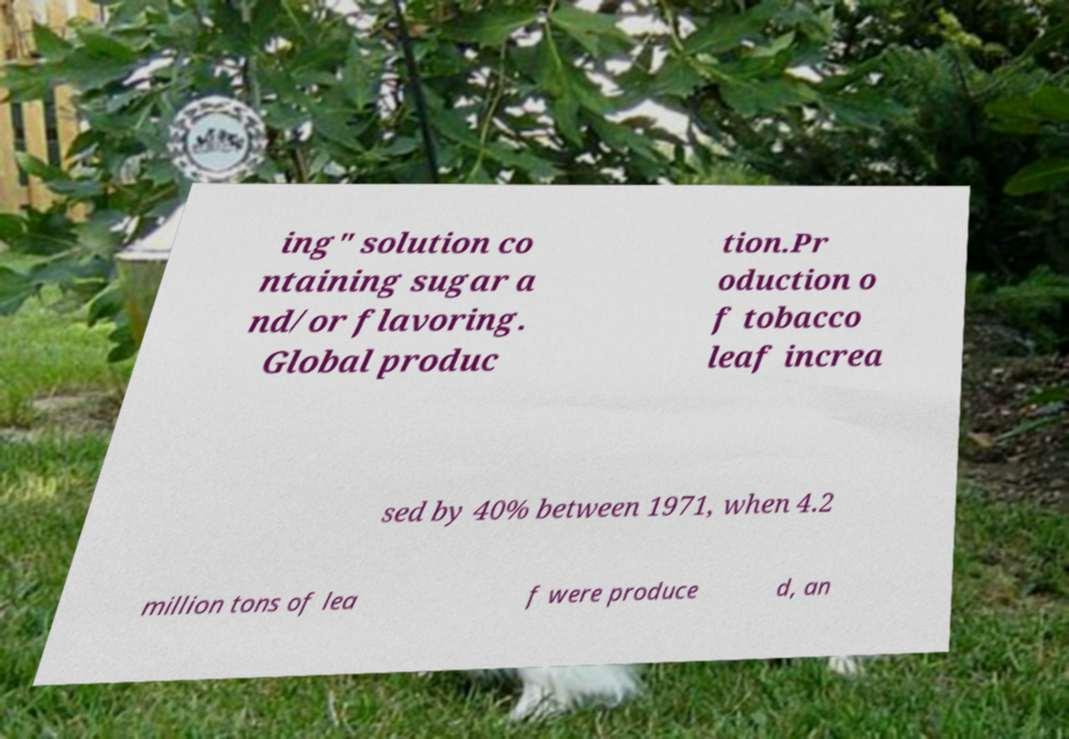Can you accurately transcribe the text from the provided image for me? ing" solution co ntaining sugar a nd/or flavoring. Global produc tion.Pr oduction o f tobacco leaf increa sed by 40% between 1971, when 4.2 million tons of lea f were produce d, an 